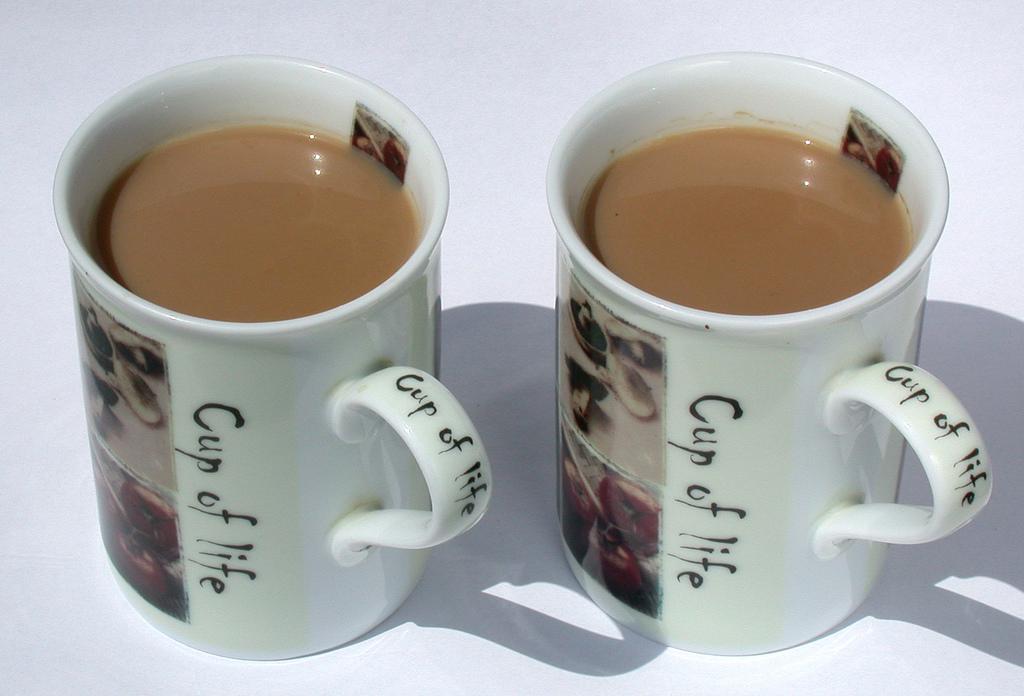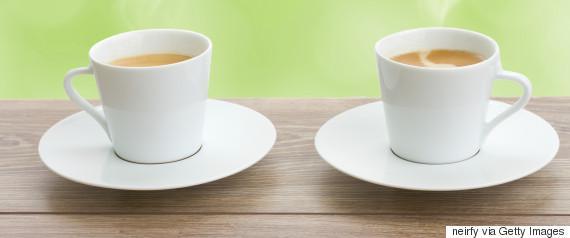The first image is the image on the left, the second image is the image on the right. For the images displayed, is the sentence "An image shows exactly two already filled round white cups sitting side-by-side horizontally without saucers, with handles turned outward." factually correct? Answer yes or no. No. The first image is the image on the left, the second image is the image on the right. Given the left and right images, does the statement "Each image shows two hot drinks served in matching cups with handles, seen at angle where the contents are visible." hold true? Answer yes or no. Yes. 